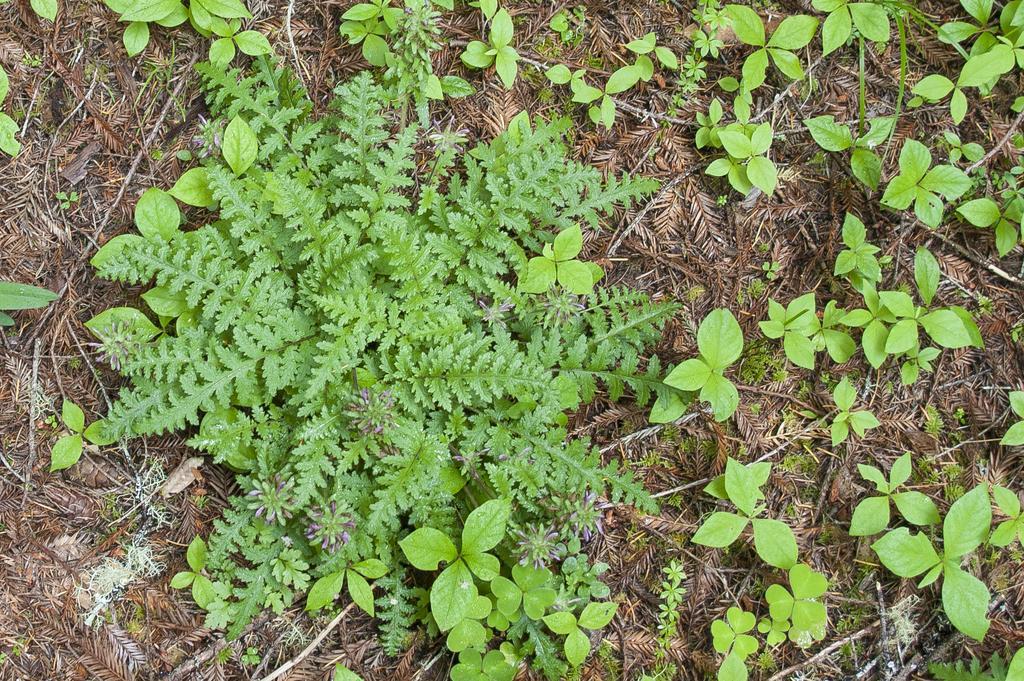Can you describe this image briefly? In this image we can see plants and twigs on the ground. 